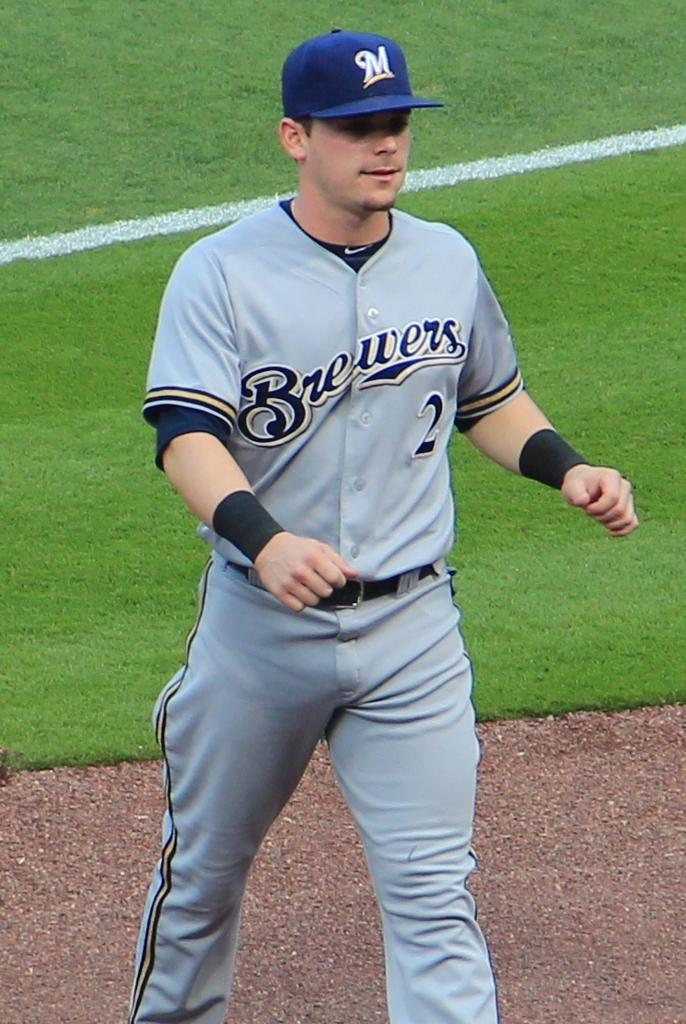<image>
Create a compact narrative representing the image presented. Brewers baseball player is walking on the outfield 